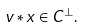Convert formula to latex. <formula><loc_0><loc_0><loc_500><loc_500>v \ast x \in C ^ { \perp } .</formula> 